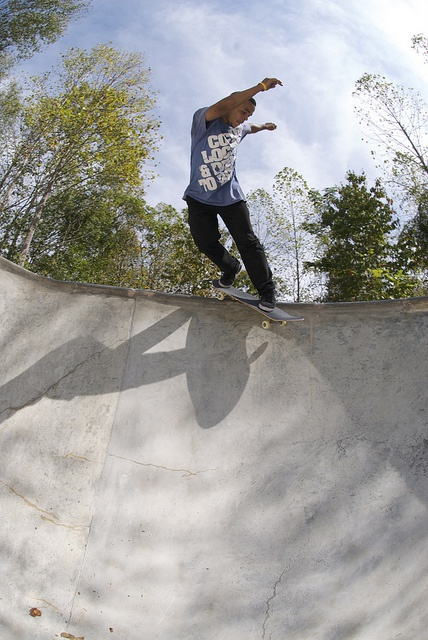Describe the objects in this image and their specific colors. I can see people in purple, black, gray, darkgray, and maroon tones and skateboard in purple, gray, black, and tan tones in this image. 